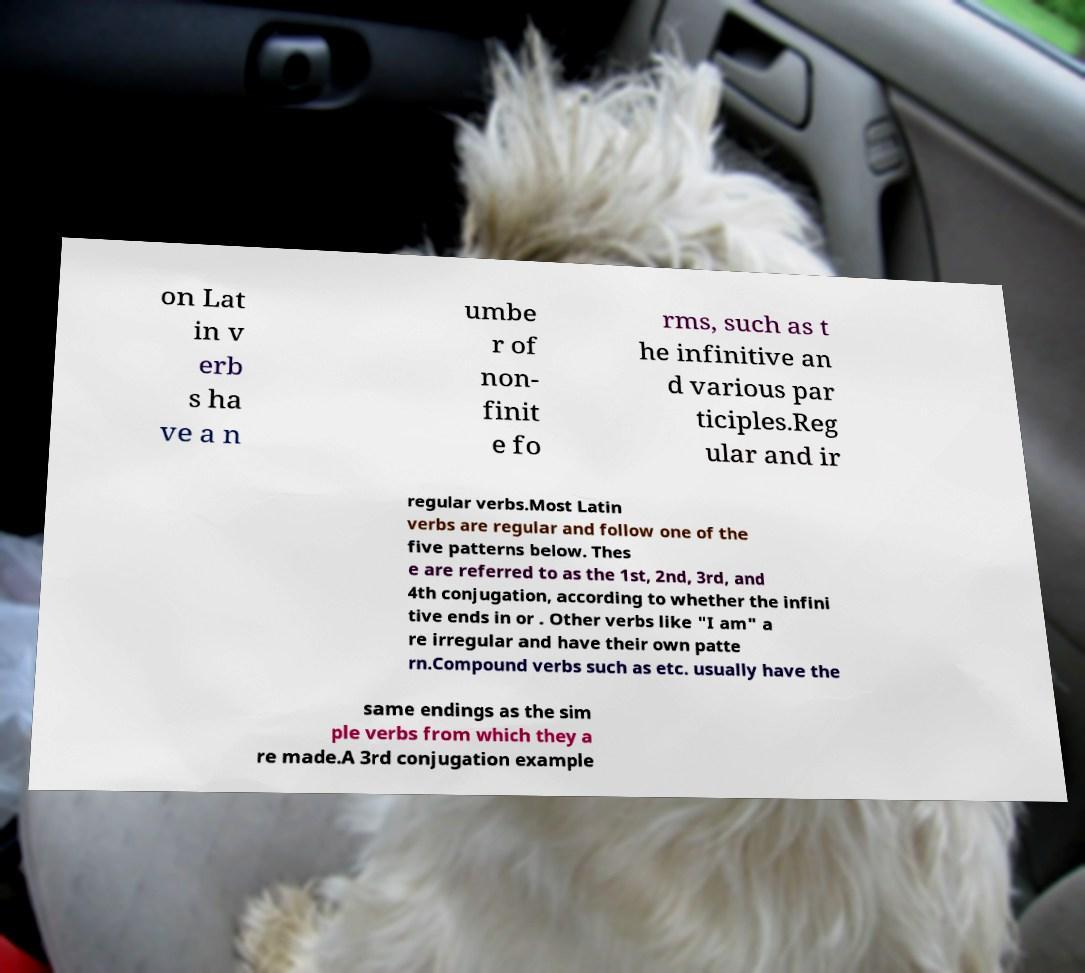What messages or text are displayed in this image? I need them in a readable, typed format. on Lat in v erb s ha ve a n umbe r of non- finit e fo rms, such as t he infinitive an d various par ticiples.Reg ular and ir regular verbs.Most Latin verbs are regular and follow one of the five patterns below. Thes e are referred to as the 1st, 2nd, 3rd, and 4th conjugation, according to whether the infini tive ends in or . Other verbs like "I am" a re irregular and have their own patte rn.Compound verbs such as etc. usually have the same endings as the sim ple verbs from which they a re made.A 3rd conjugation example 